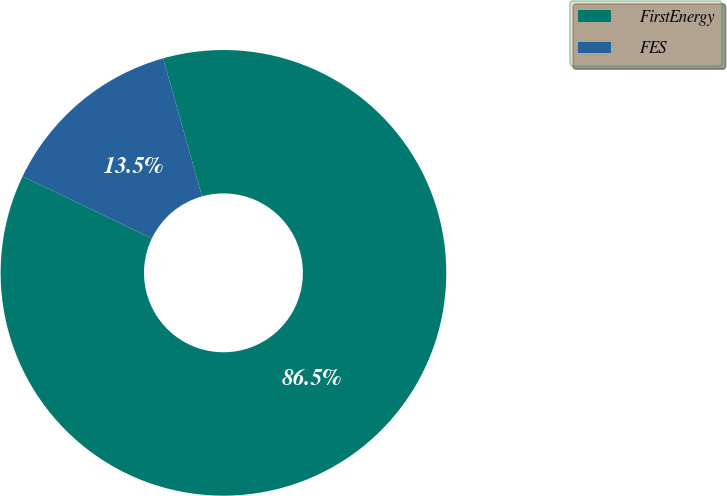Convert chart to OTSL. <chart><loc_0><loc_0><loc_500><loc_500><pie_chart><fcel>FirstEnergy<fcel>FES<nl><fcel>86.49%<fcel>13.51%<nl></chart> 